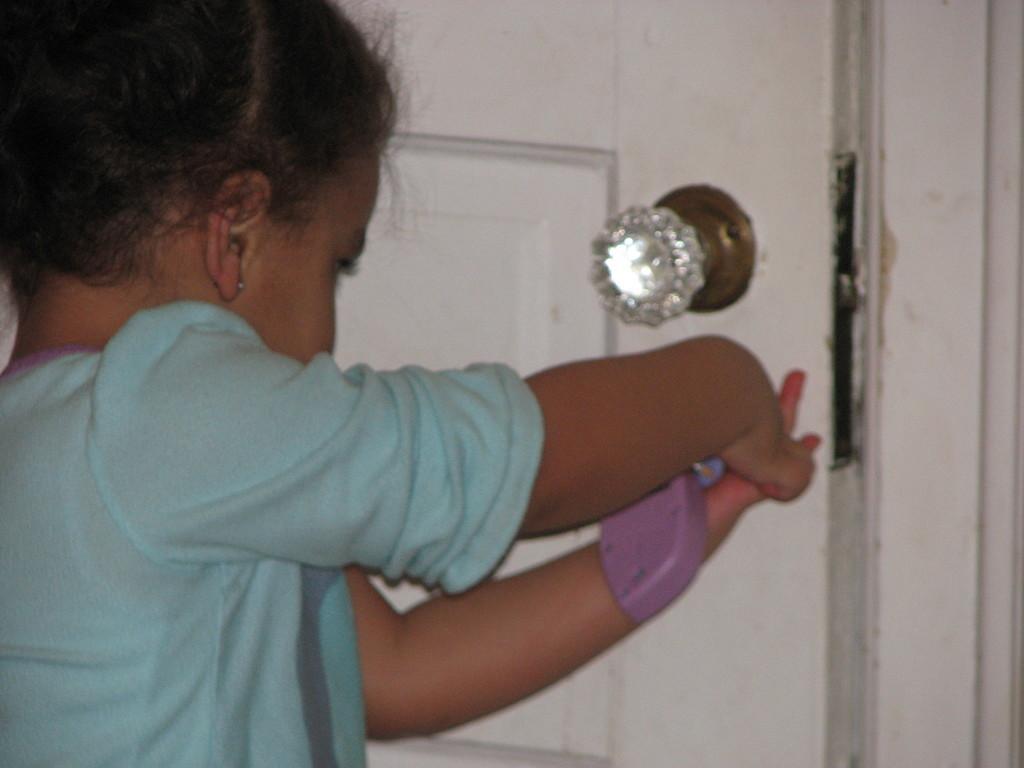In one or two sentences, can you explain what this image depicts? In this image I see a girl, who is wearing a blue colored t-shirt and in the background I see a door which is of white in color and the door knob is of silver color. 